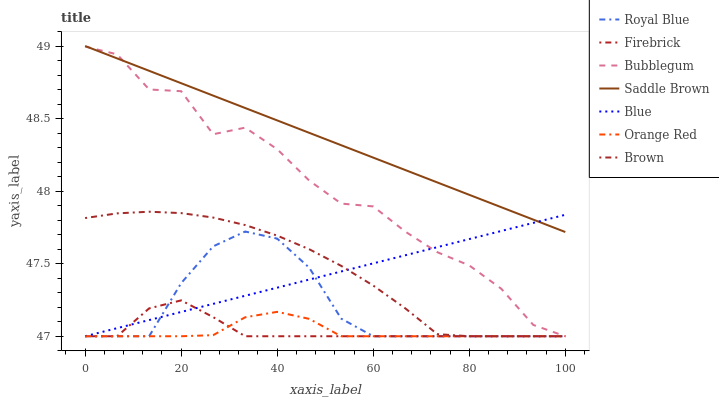Does Orange Red have the minimum area under the curve?
Answer yes or no. Yes. Does Saddle Brown have the maximum area under the curve?
Answer yes or no. Yes. Does Brown have the minimum area under the curve?
Answer yes or no. No. Does Brown have the maximum area under the curve?
Answer yes or no. No. Is Blue the smoothest?
Answer yes or no. Yes. Is Bubblegum the roughest?
Answer yes or no. Yes. Is Brown the smoothest?
Answer yes or no. No. Is Brown the roughest?
Answer yes or no. No. Does Blue have the lowest value?
Answer yes or no. Yes. Does Saddle Brown have the lowest value?
Answer yes or no. No. Does Saddle Brown have the highest value?
Answer yes or no. Yes. Does Brown have the highest value?
Answer yes or no. No. Is Brown less than Saddle Brown?
Answer yes or no. Yes. Is Saddle Brown greater than Orange Red?
Answer yes or no. Yes. Does Brown intersect Blue?
Answer yes or no. Yes. Is Brown less than Blue?
Answer yes or no. No. Is Brown greater than Blue?
Answer yes or no. No. Does Brown intersect Saddle Brown?
Answer yes or no. No. 